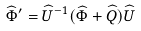<formula> <loc_0><loc_0><loc_500><loc_500>\widehat { \Phi } ^ { \prime } = \widehat { U } ^ { - 1 } ( \widehat { \Phi } + \widehat { Q } ) \widehat { U }</formula> 